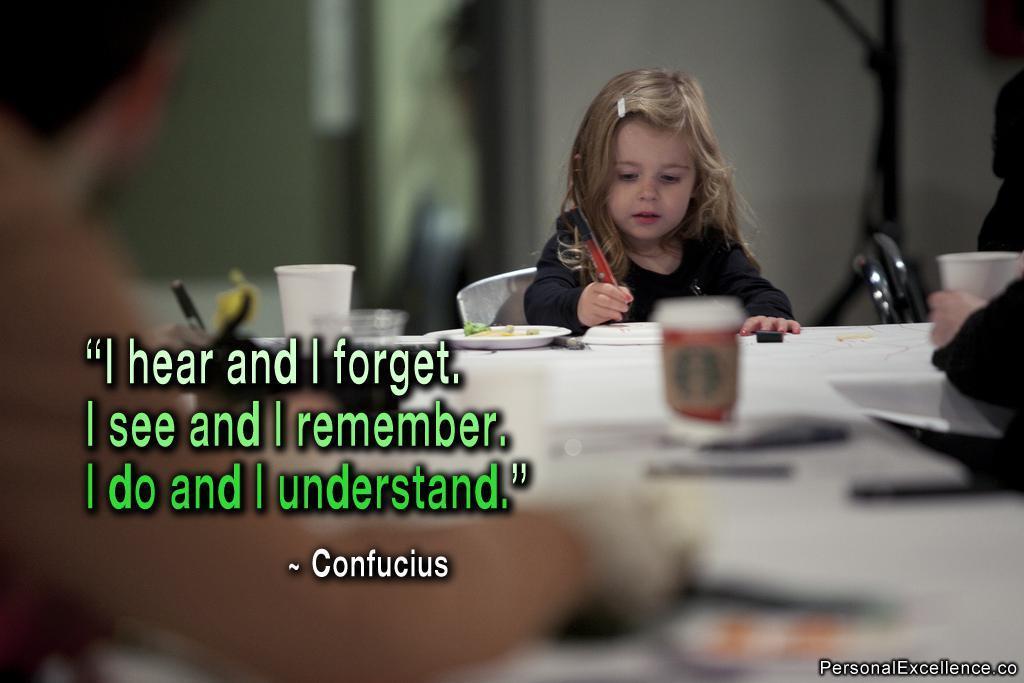Can you describe this image briefly? In this image I see a child who is sitting on a chair and there is a table in front and lot of things on it. 